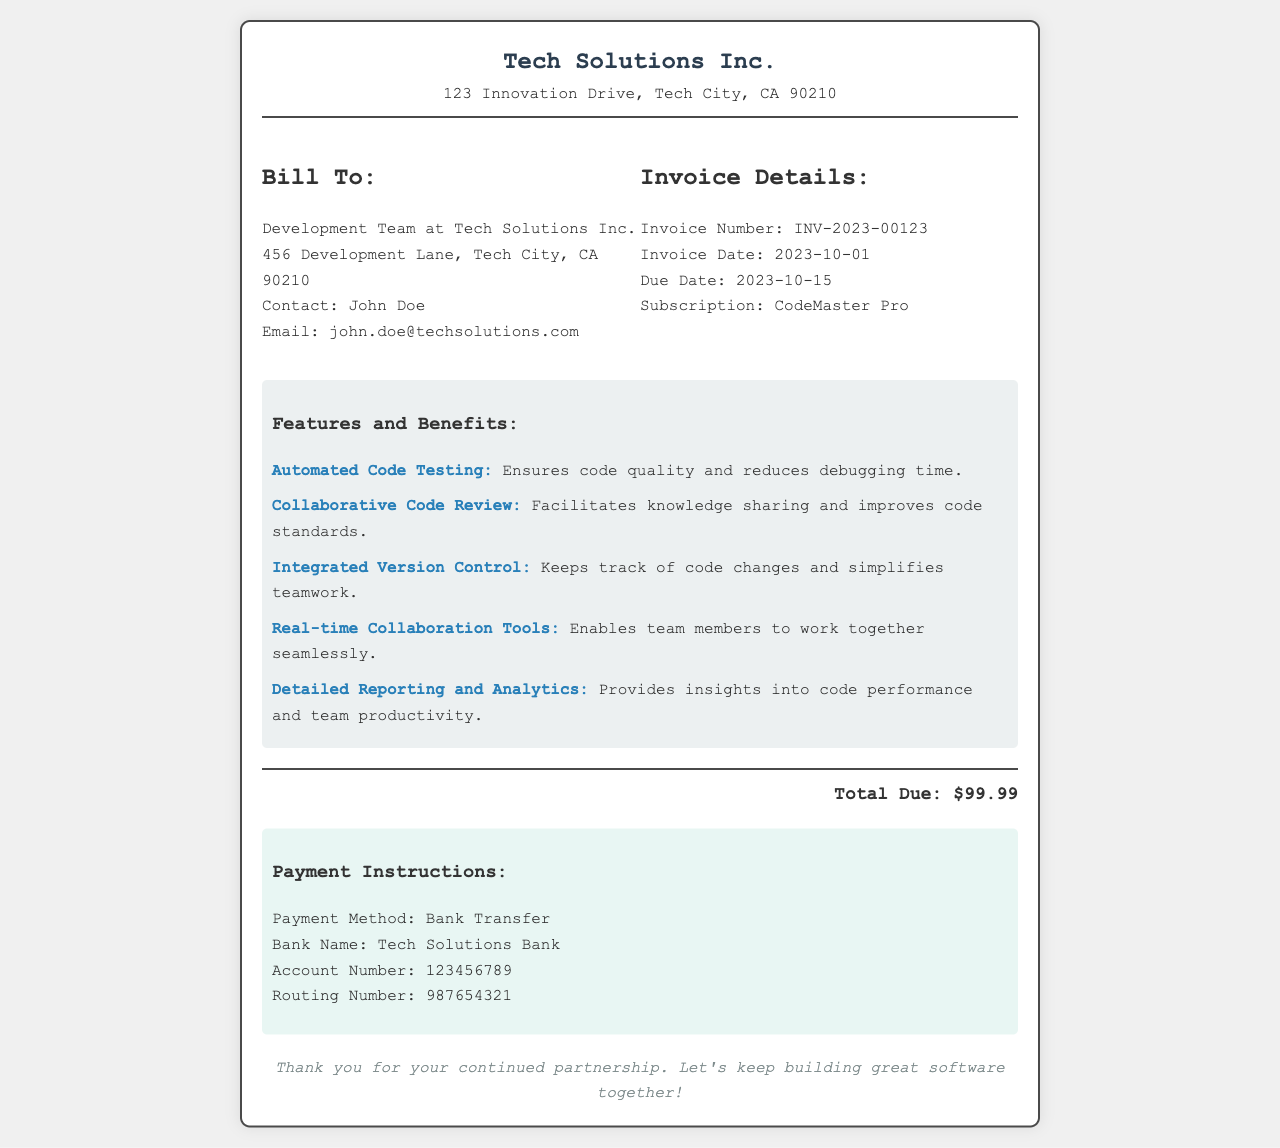what is the invoice number? The invoice number is stated clearly in the invoice details section.
Answer: INV-2023-00123 who is the billing contact? The billing contact is listed under the billing details section of the document.
Answer: John Doe what is the invoice date? The invoice date is explicitly mentioned in the invoice details section.
Answer: 2023-10-01 how much is the total due? The total due is prominently displayed at the bottom of the invoice.
Answer: $99.99 which subscription is being billed? The subscription type is detailed in the invoice information section.
Answer: CodeMaster Pro what are the payment instructions? The payment instructions are provided in a separate section for clarity.
Answer: Bank Transfer what feature reduces debugging time? The feature that reduces debugging time is mentioned in the features section.
Answer: Automated Code Testing which feature improves code standards? The feature that facilitates knowledge sharing is noted in the benefits breakdown.
Answer: Collaborative Code Review how can the team collaborate in real-time? The capability for real-time collaboration is highlighted as a feature.
Answer: Real-time Collaboration Tools 